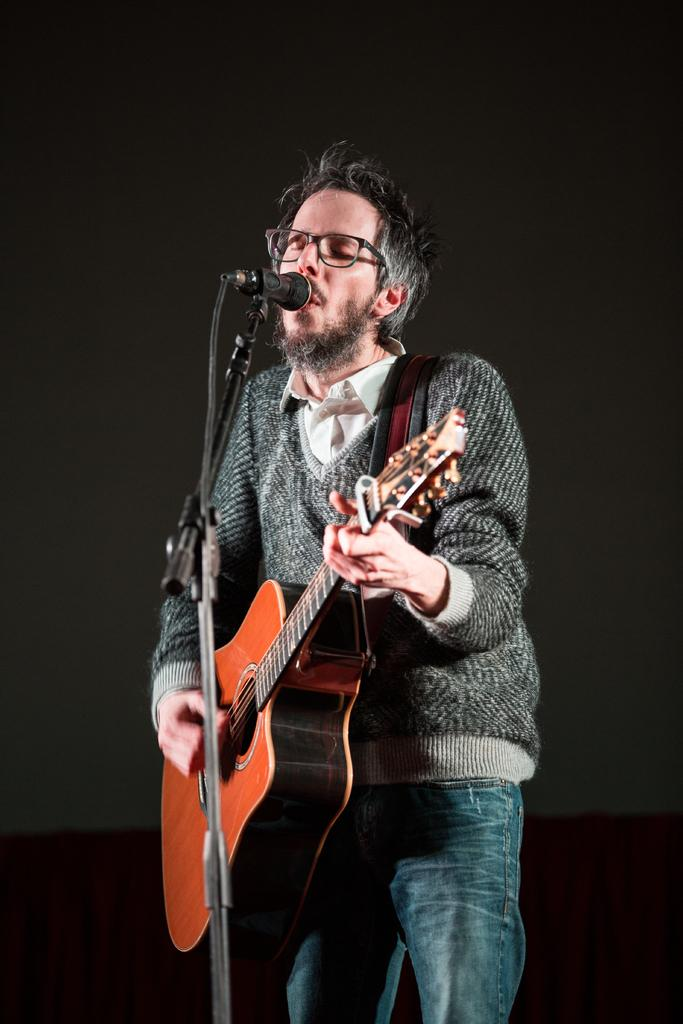What is the man in the image doing? The man is singing and playing a guitar. What object is the man using to amplify his voice? There is a microphone in the image. What type of pin can be seen holding the man's bathrobe in the image? There is no bathrobe or pin present in the image; the man is wearing a shirt and playing a guitar. What kind of cast is visible on the man's arm in the image? There is no cast present in the image; the man is playing a guitar with both hands. 